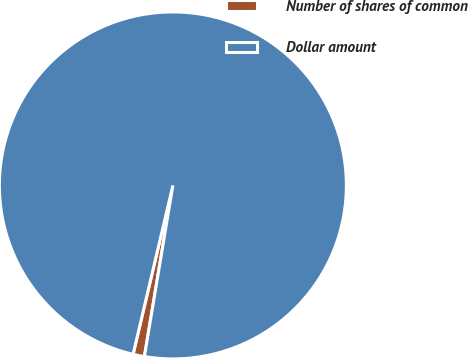Convert chart. <chart><loc_0><loc_0><loc_500><loc_500><pie_chart><fcel>Number of shares of common<fcel>Dollar amount<nl><fcel>1.06%<fcel>98.94%<nl></chart> 